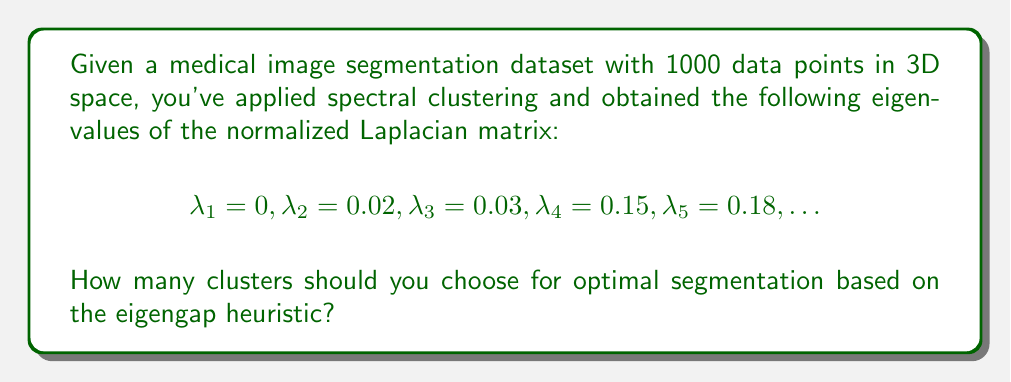Show me your answer to this math problem. To determine the optimal number of clusters using the eigengap heuristic in spectral clustering, we follow these steps:

1. Examine the eigenvalues of the normalized Laplacian matrix, which are given as:
   $$\lambda_1 = 0, \lambda_2 = 0.02, \lambda_3 = 0.03, \lambda_4 = 0.15, \lambda_5 = 0.18, \ldots$$

2. The eigengap heuristic suggests choosing the number of clusters $k$ where there is the largest gap between consecutive eigenvalues.

3. Calculate the differences between consecutive eigenvalues:
   $$\lambda_2 - \lambda_1 = 0.02 - 0 = 0.02$$
   $$\lambda_3 - \lambda_2 = 0.03 - 0.02 = 0.01$$
   $$\lambda_4 - \lambda_3 = 0.15 - 0.03 = 0.12$$
   $$\lambda_5 - \lambda_4 = 0.18 - 0.15 = 0.03$$

4. The largest gap is between $\lambda_3$ and $\lambda_4$, with a difference of 0.12.

5. The optimal number of clusters is the index before this largest gap, which is 3.

Therefore, based on the eigengap heuristic, we should choose 3 clusters for optimal segmentation of the medical image data.
Answer: 3 clusters 